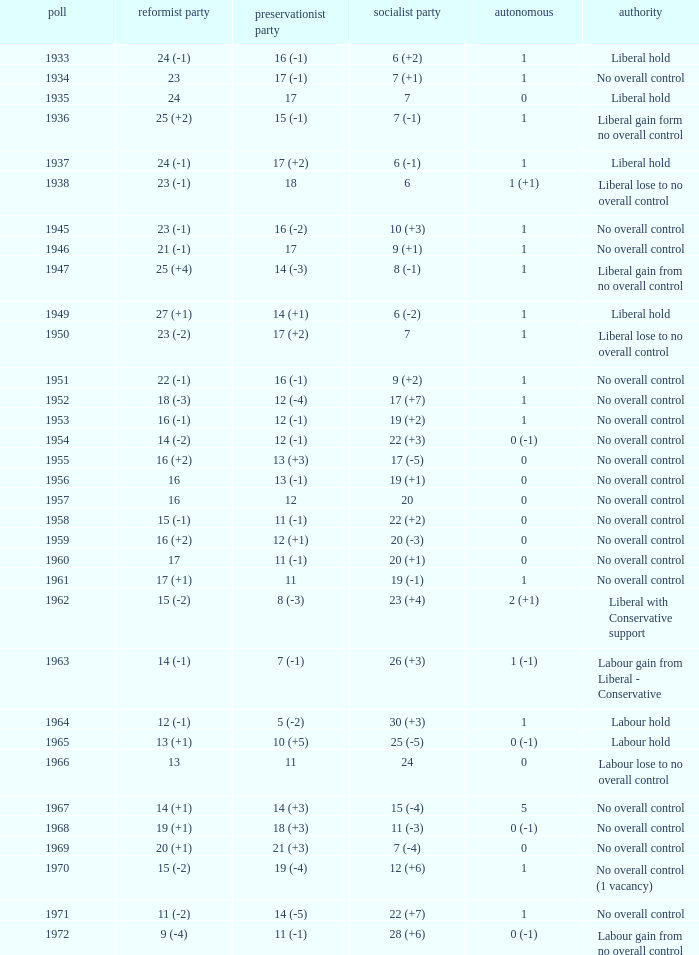What was the control for the year with a Conservative Party result of 10 (+5)? Labour hold. 